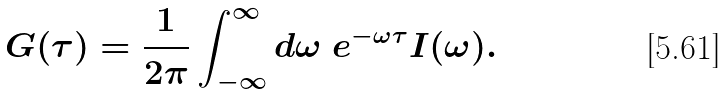<formula> <loc_0><loc_0><loc_500><loc_500>G ( \tau ) = \frac { 1 } { 2 \pi } \int _ { - \infty } ^ { \infty } d \omega \ e ^ { - \omega \tau } I ( \omega ) .</formula> 